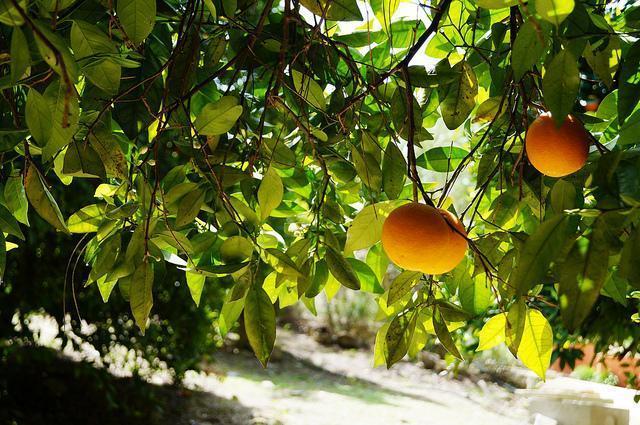How many oranges are there on the tree?
Give a very brief answer. 2. How many fruit is on the tree?
Give a very brief answer. 2. How many oranges are in the photo?
Give a very brief answer. 2. 